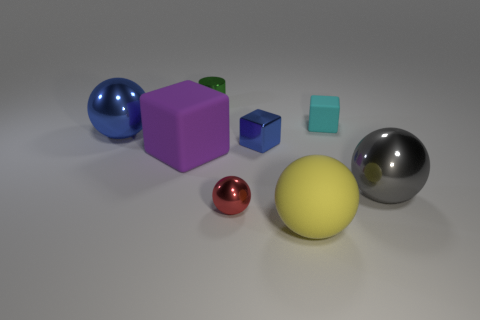What is the material of the small cylinder?
Ensure brevity in your answer.  Metal. What number of other objects are the same material as the cyan object?
Your response must be concise. 2. What is the size of the sphere that is to the left of the blue shiny block and in front of the large purple cube?
Keep it short and to the point. Small. There is a tiny object to the right of the big matte object on the right side of the red sphere; what is its shape?
Your answer should be compact. Cube. Is there anything else that has the same shape as the tiny green thing?
Ensure brevity in your answer.  No. Is the number of big blue shiny spheres that are in front of the big purple block the same as the number of red metal spheres?
Ensure brevity in your answer.  No. Does the small metallic block have the same color as the small metallic thing that is on the left side of the tiny red shiny thing?
Offer a very short reply. No. The metal object that is both in front of the cyan rubber thing and to the left of the red metallic ball is what color?
Your answer should be compact. Blue. What number of blue metal things are behind the rubber block in front of the big blue object?
Ensure brevity in your answer.  2. Is there a large yellow object that has the same shape as the gray thing?
Offer a terse response. Yes. 